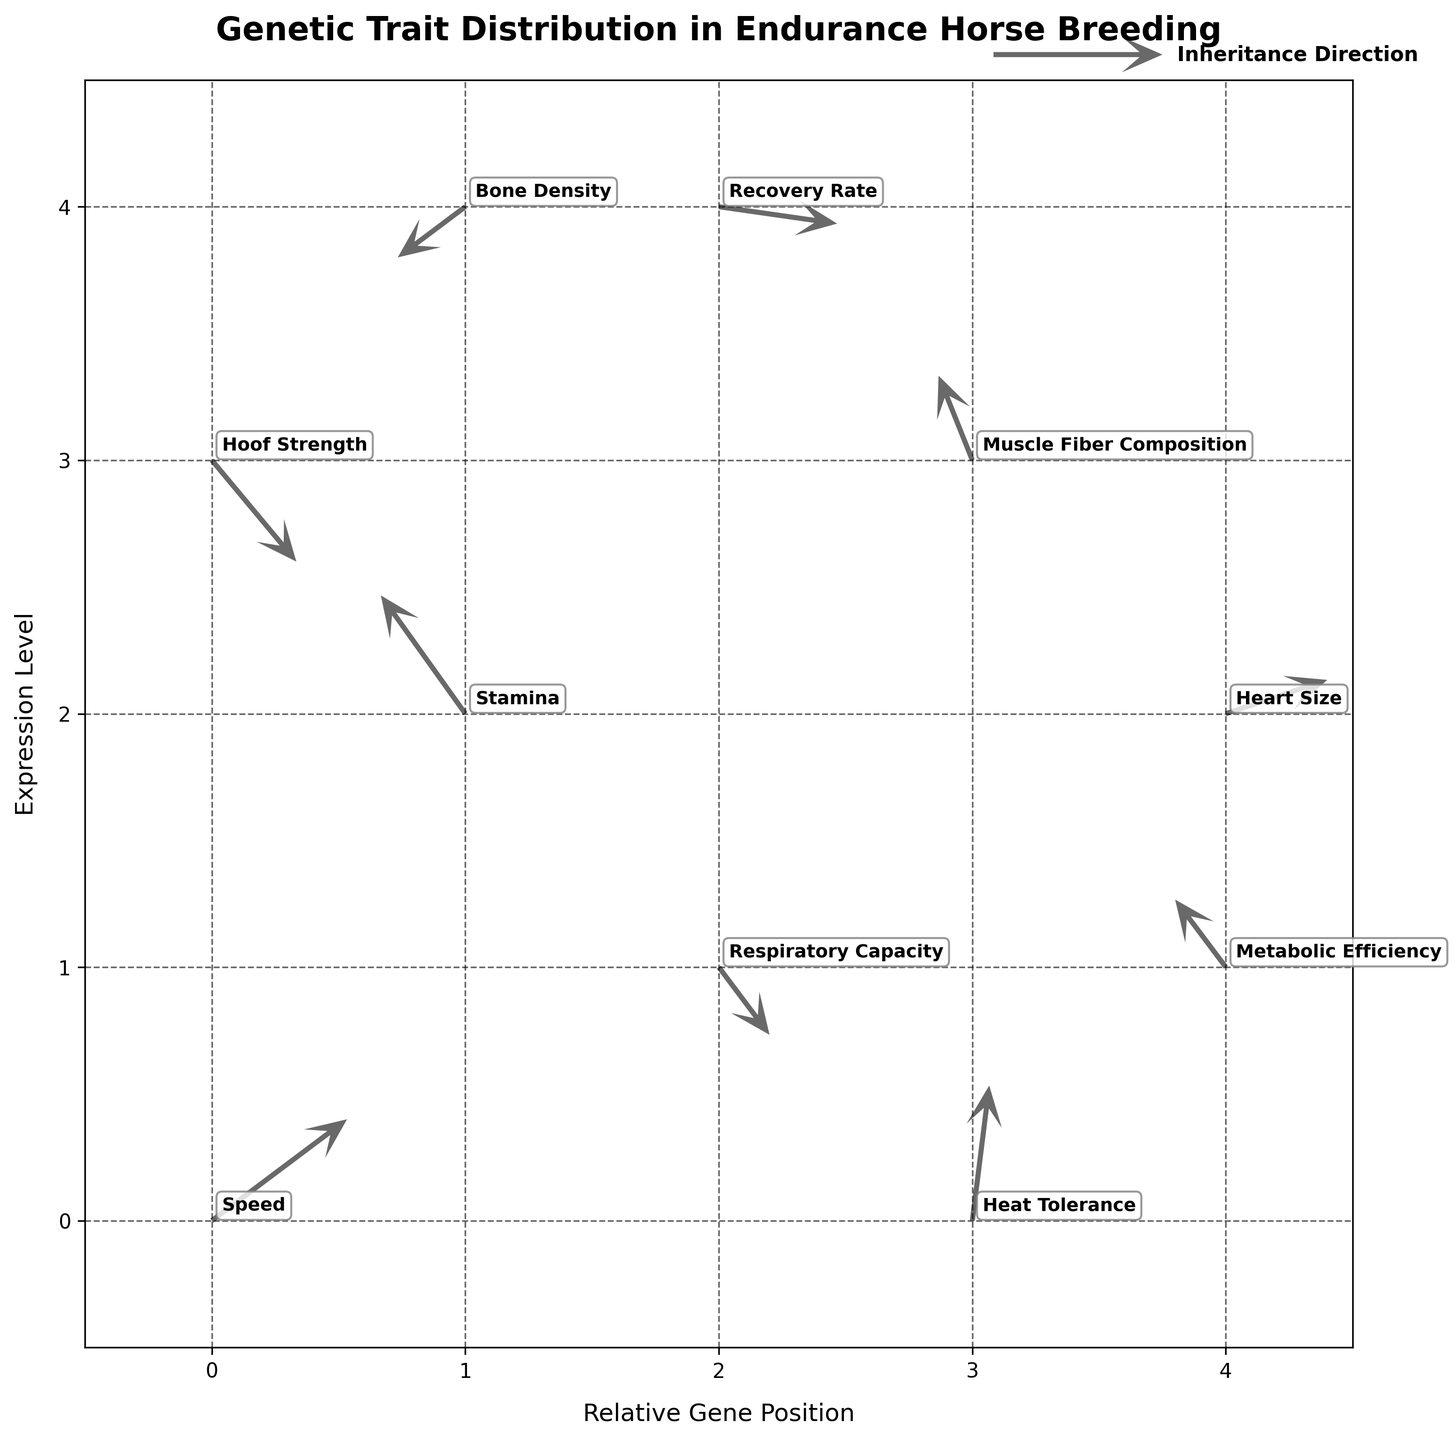What's the title of the plot? The title of the plot is prominently displayed at the top of the figure. It says, "Genetic Trait Distribution in Endurance Horse Breeding".
Answer: Genetic Trait Distribution in Endurance Horse Breeding Which direction is the arrow for "Speed" pointing? The arrow for the "Speed" trait starts at (0,0) and points in the direction of the vector (0.8, 0.6). This means it is pointing diagonally up and to the right.
Answer: Diagonally up and to the right How many traits are shown in the plot? By counting the labeled traits, we can see there are 10 data points, each representing a unique trait in the plot.
Answer: 10 What is the trait with the longest arrow? Comparing the magnitudes of each vector, the arrow representing "Heat Tolerance" (magnitude = sqrt(0.1^2 + 0.8^2)) is the longest, calculated as roughly 0.81.
Answer: Heat Tolerance Which trait shows the largest increase in the x-direction? The trait with the largest increase in the x-direction corresponds to the arrow with the highest positive 'u' value, which is "Speed" with u = 0.8.
Answer: Speed What is the position and direction of the "Bone Density" trait arrow? The "Bone Density" arrow is located at position (1, 4), and its direction is (-0.4, -0.3), pointing downwards and to the left.
Answer: (1, 4), downwards and to the left Is "Hoof Strength" increasing or decreasing in y-coordinate? By observing the arrow for "Hoof Strength" located at (0,3), we see the 'v' component is -0.6, indicating a decrease in the y-coordinate.
Answer: Decreasing Which trait shows the least change in the x-value? The trait with the least change in x is the arrow with the smallest absolute value of 'u', which is "Muscle Fiber Composition" with u = -0.2.
Answer: Muscle Fiber Composition What is the combined change in y-values for "Muscle Fiber Composition" and "Heart Size"? The y-change for "Muscle Fiber Composition" is 0.5 and for "Heart Size" is 0.2. Adding these together results in a combined change of 0.7.
Answer: 0.7 Which trait has a negative x-change but a positive y-change? Arrow directions where 'u' is negative, and 'v' is positive are considered. "Stamina" has u = -0.5 and v = 0.7, fitting this criteria.
Answer: Stamina 